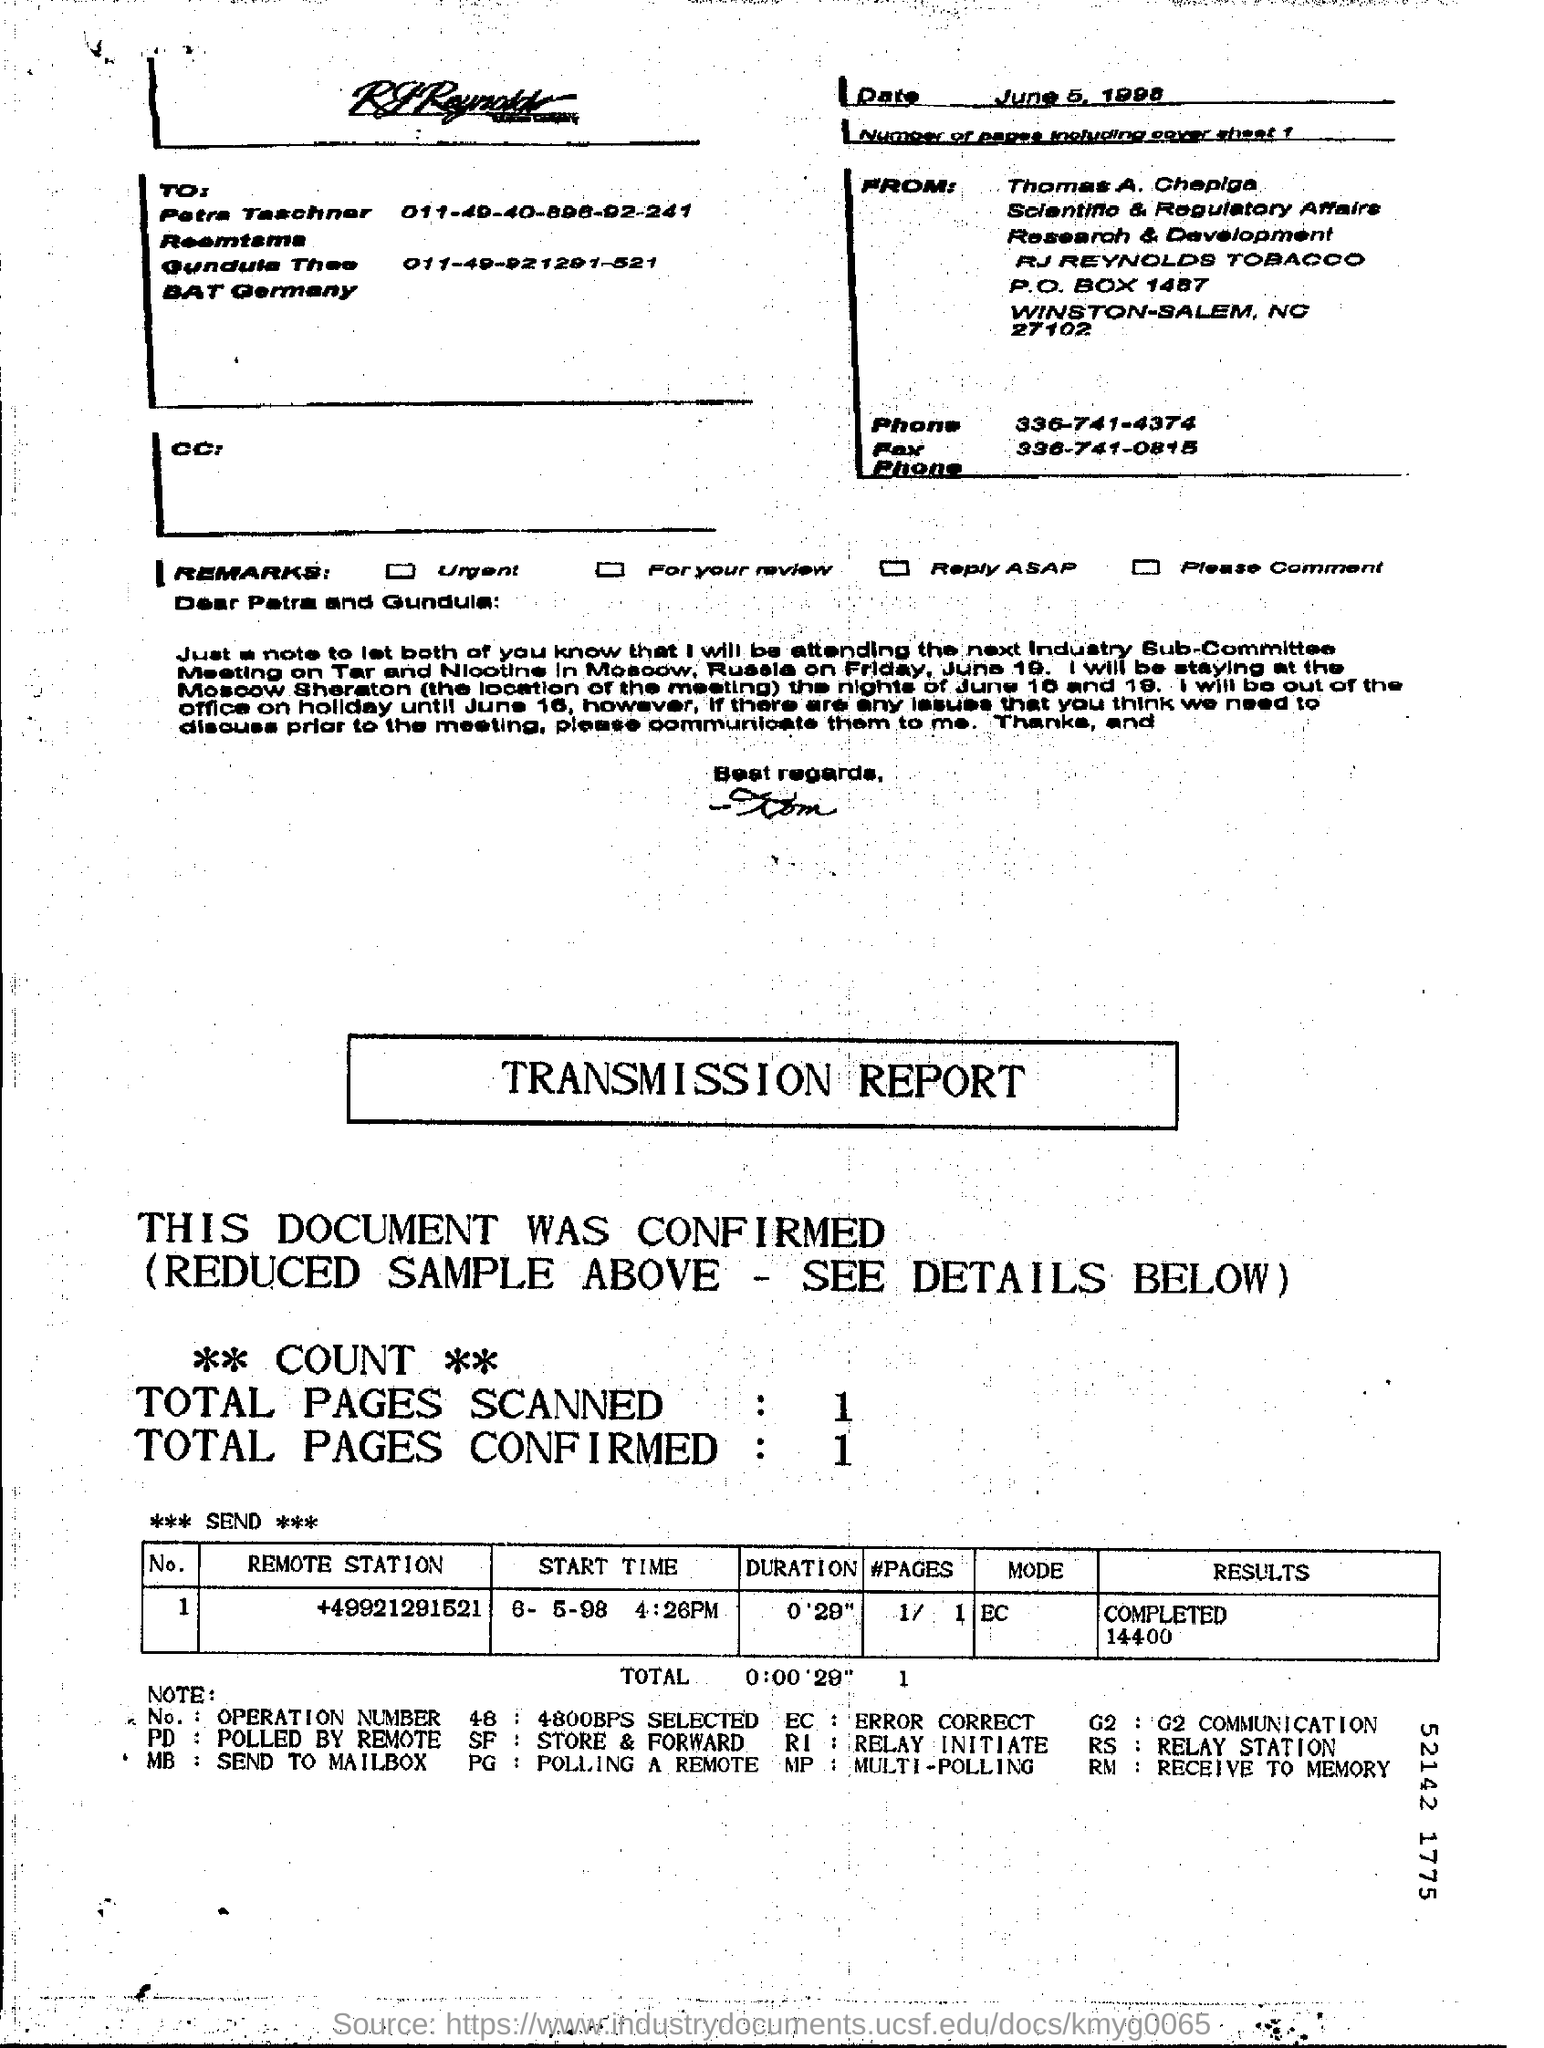How many pages are there including cover sheet?
Offer a terse response. 1. What is the remote station number?
Your answer should be compact. +49921291521. What is the mode?
Provide a short and direct response. EC. In total how many pages were confirmed?
Provide a succinct answer. 1. 